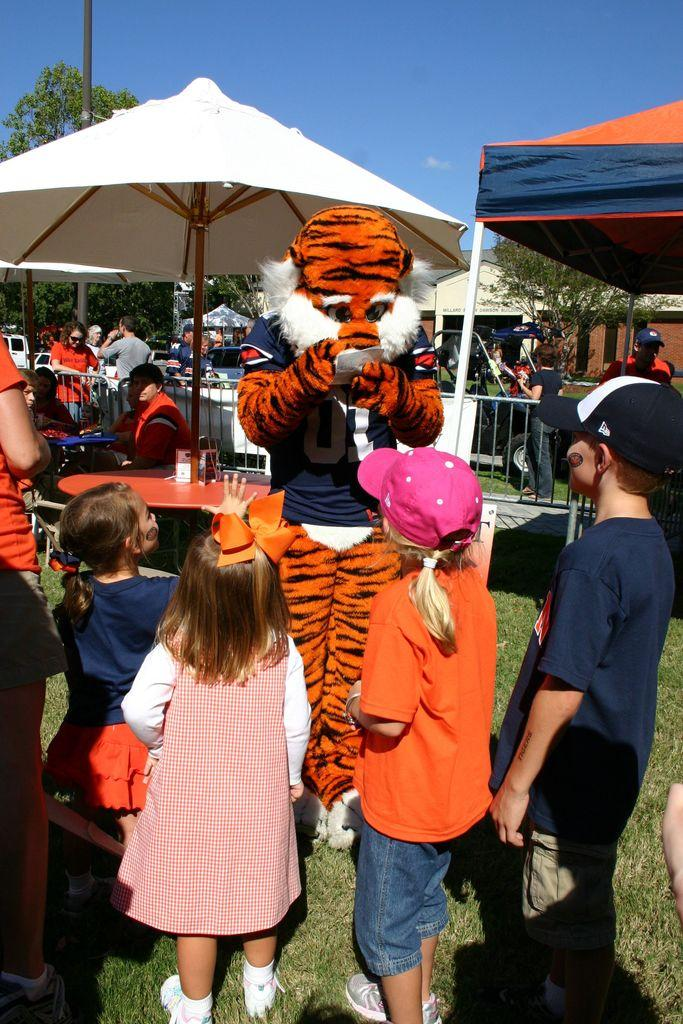What are the persons in the image wearing? The persons in the image are wearing costumes. What are the children doing in the image? The children are standing on the ground in the image. What are the persons sitting on in the image? The persons sitting on chairs in the image. What type of shade is provided in the image? There are parasols in the image for shade. What is being used for cooking in the image? There are grills in the image for cooking. What type of temporary shelter is present in the image? There is a tent in the image. What type of vegetation is visible in the image? There are trees in the image. What type of structures are visible in the image? There are buildings in the image. What is visible in the sky in the image? The sky is visible in the image, and there are clouds in the sky. What type of holiday is being celebrated in the image? There is no indication of a specific holiday being celebrated in the image. What type of parent is present in the image? There is no mention of a parent in the image. 